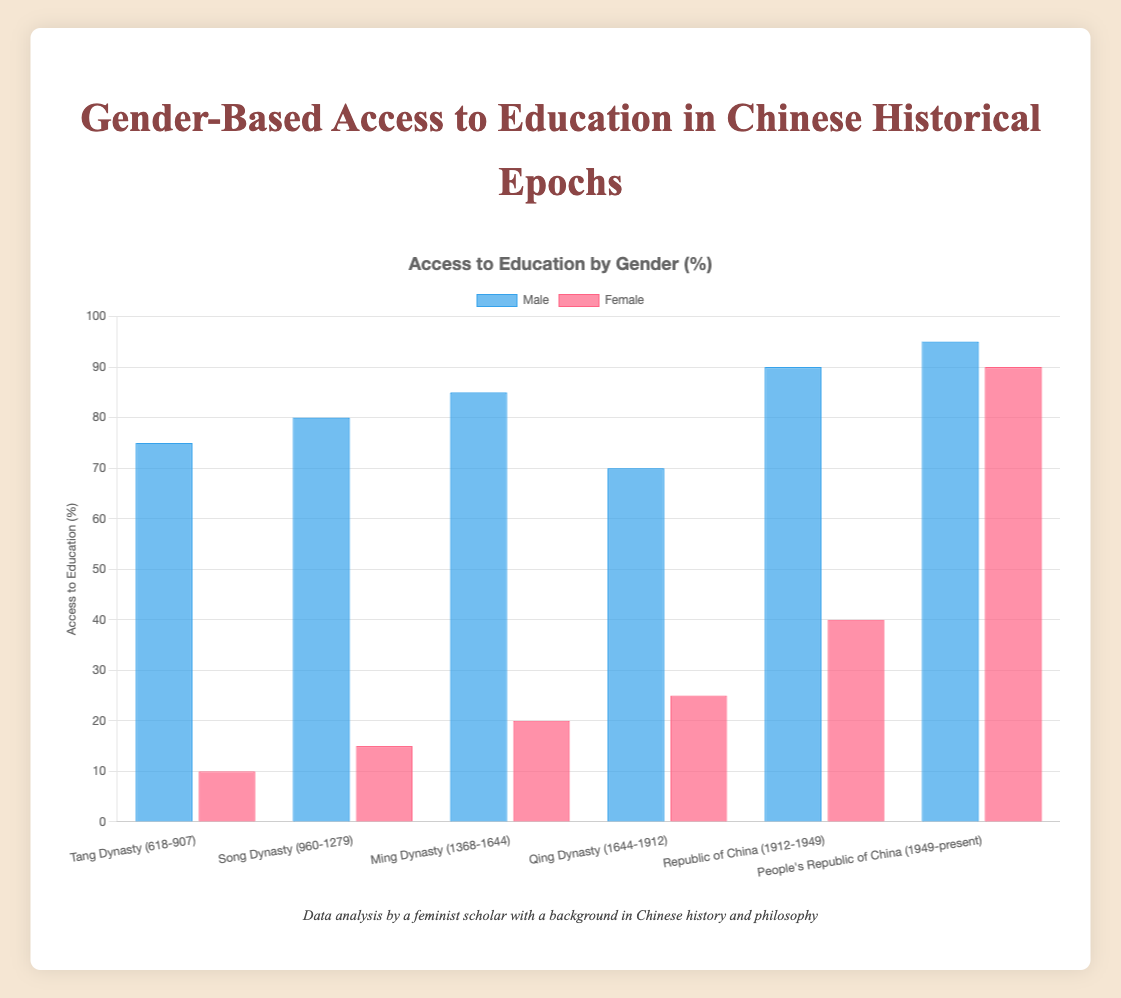Which epoch shows the highest access to education for males? Look at the heights of the blue bars representing male access to education for each epoch. The People's Republic of China has the highest bar.
Answer: People's Republic of China (1949-present) Compare female access to education in the Tang Dynasty and People's Republic of China. Look at the red bars representing female access for these two periods. In the Tang Dynasty, the bar is at 10%, and in the People's Republic of China, it is at 90%.
Answer: People's Republic of China (1949-present) > Tang Dynasty (618-907) What is the total access to education (male and female combined) during the Ming Dynasty? Add the access percentages for males (85) and females (20) during the Ming Dynasty. 85 + 20 = 105
Answer: 105 Between the Song Dynasty and the Qing Dynasty, which had a smaller gap in educational access between genders? Subtract female access percentages from male percentages for both epochs: Song Dynasty: 80 - 15 = 65, Qing Dynasty: 70 - 25 = 45. The Qing Dynasty has a smaller gap.
Answer: Qing Dynasty (1644-1912) How did female access to education change from the Qing Dynasty to the Republic of China? Subtract female access during the Qing Dynasty (25) from female access during the Republic of China (40). 40 - 25 = 15
Answer: Increased by 15 What is the average access to education for females across all epochs? Sum all female access percentages and divide by the number of epochs: (10 + 15 + 20 + 25 + 40 + 90)/6 = 200/6 ≈ 33.33%
Answer: 33.33% In which epoch did male educational access decrease compared to the previous epoch? Compare the heights of the blue bars from one epoch to the next. Male access is lower in the Qing Dynasty (70) compared to the Ming Dynasty (85).
Answer: Qing Dynasty (1644-1912) Which gender had the lowest access to education during the Tang Dynasty? Compare the heights of the blue bar (male) and red bar (female) for the Tang Dynasty. The female bar is lower at 10%, compared to the male at 75%.
Answer: Female 